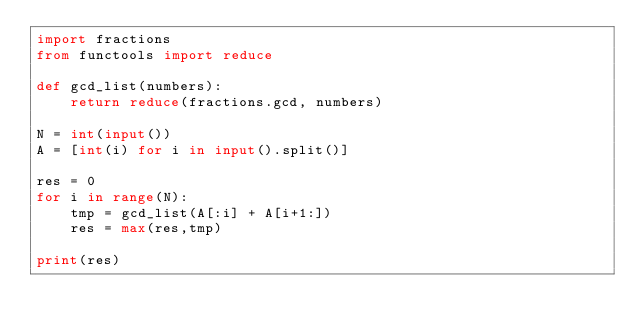Convert code to text. <code><loc_0><loc_0><loc_500><loc_500><_Python_>import fractions
from functools import reduce

def gcd_list(numbers):
    return reduce(fractions.gcd, numbers)

N = int(input())
A = [int(i) for i in input().split()]

res = 0
for i in range(N):
    tmp = gcd_list(A[:i] + A[i+1:])
    res = max(res,tmp)

print(res)
</code> 